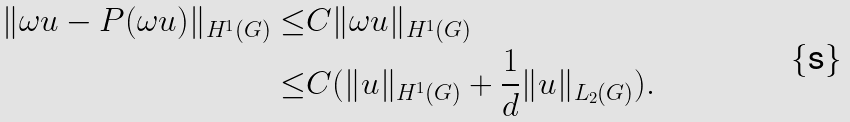<formula> <loc_0><loc_0><loc_500><loc_500>\| \omega u - P ( \omega u ) \| _ { H ^ { 1 } ( G ) } \leq & C \| \omega u \| _ { H ^ { 1 } ( G ) } \\ \leq & C ( \| u \| _ { H ^ { 1 } ( G ) } + \frac { 1 } { d } \| u \| _ { L _ { 2 } ( G ) } ) .</formula> 